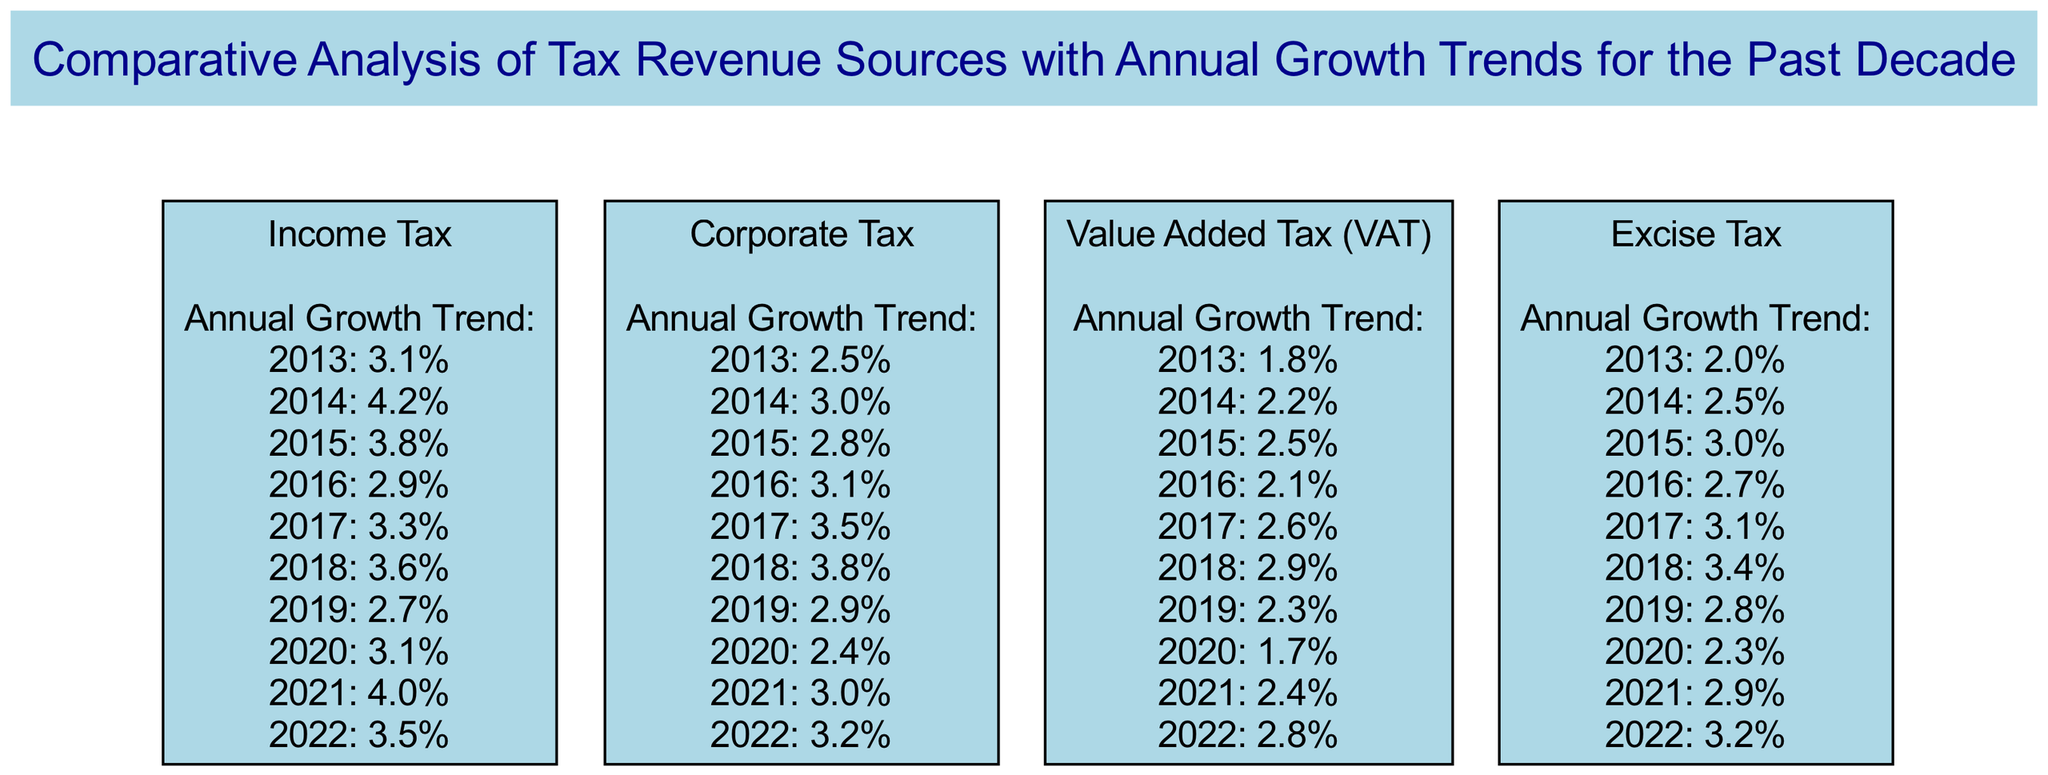What is the annual growth percentage for Income Tax in 2018? The diagram indicates that in 2018, the growth percentage for Income Tax is 3.6%. This value can be directly found under the Income Tax block in the annual growth trend list for that year.
Answer: 3.6% Which tax revenue source had the highest growth percentage in 2017? According to the comparative analysis, Corporate Tax recorded the highest growth percentage in 2017 at 3.5%, when evaluated against the other tax revenue sources listed in the diagram.
Answer: Corporate Tax How many tax revenue sources are depicted in the diagram? The diagram displays a total of four tax revenue sources: Income Tax, Corporate Tax, Value Added Tax (VAT), and Excise Tax. This can be counted directly from the blocks presented in the diagram.
Answer: 4 What was the growth percentage trend for Value Added Tax in 2020? The diagram shows that the growth percentage for Value Added Tax in 2020 is 1.7%. This specific value is mentioned in the annual growth trend list under the Value Added Tax block.
Answer: 1.7% Which tax revenue source had the lowest annual growth rate in 2019? In 2019, the growth percentage for Value Added Tax is the lowest at 2.3%. This value is noted in the annual growth trends and can be compared with the other sources for that year.
Answer: Value Added Tax What overall trend can be observed for Excise Tax between 2015 and 2022? The diagram indicates that Excise Tax showed a generally upward trend in growth percentages from 2015 to 2022, with a slight decrease in 2020, highlighting a consistency in growth following that dip.
Answer: Upward trend In what year did Corporate Tax experience the lowest growth percentage? Corporate Tax had its lowest growth percentage of 2.4% in 2020, which can be identified when reviewing the listed annual growth percentages for that particular tax revenue source.
Answer: 2020 What is the relationship between Income Tax and VAT in terms of growth percentage in 2019? In 2019, Income Tax had a growth percentage of 2.7%, while VAT had a lower growth percentage of 2.3%. This relationship demonstrates that Income Tax performed better than VAT that year, which can be inferred directly from their respective data.
Answer: Income Tax > VAT Which tax revenue source maintained a consistent growth trend from 2013 to 2014? The data shows that Income Tax, Corporate Tax, and Excise Tax all had consistent growth trends from 2013 to 2014, looking at their percentage changes, which can be easily confirmed by visual comparison across the blocks.
Answer: Income Tax, Corporate Tax, Excise Tax 